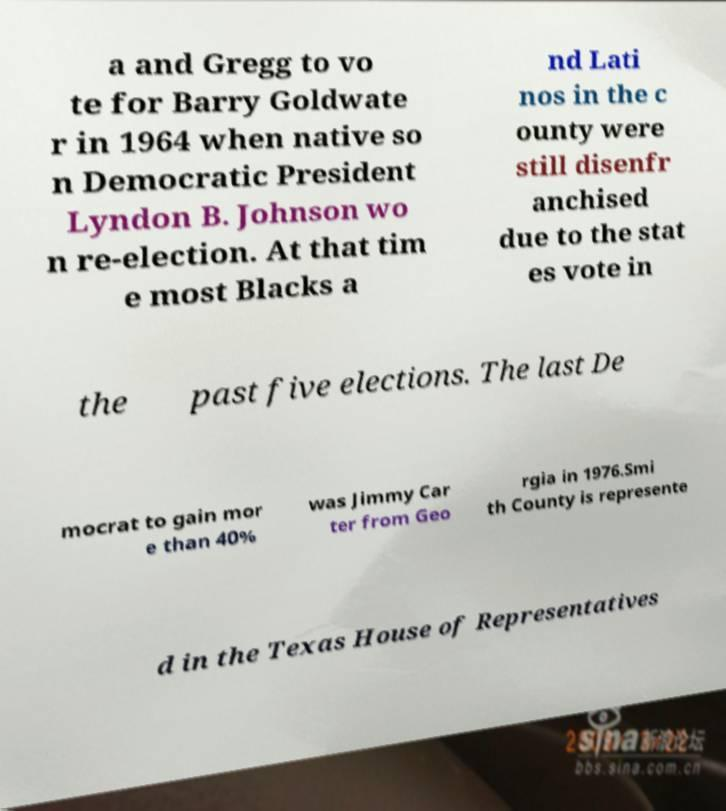I need the written content from this picture converted into text. Can you do that? a and Gregg to vo te for Barry Goldwate r in 1964 when native so n Democratic President Lyndon B. Johnson wo n re-election. At that tim e most Blacks a nd Lati nos in the c ounty were still disenfr anchised due to the stat es vote in the past five elections. The last De mocrat to gain mor e than 40% was Jimmy Car ter from Geo rgia in 1976.Smi th County is represente d in the Texas House of Representatives 